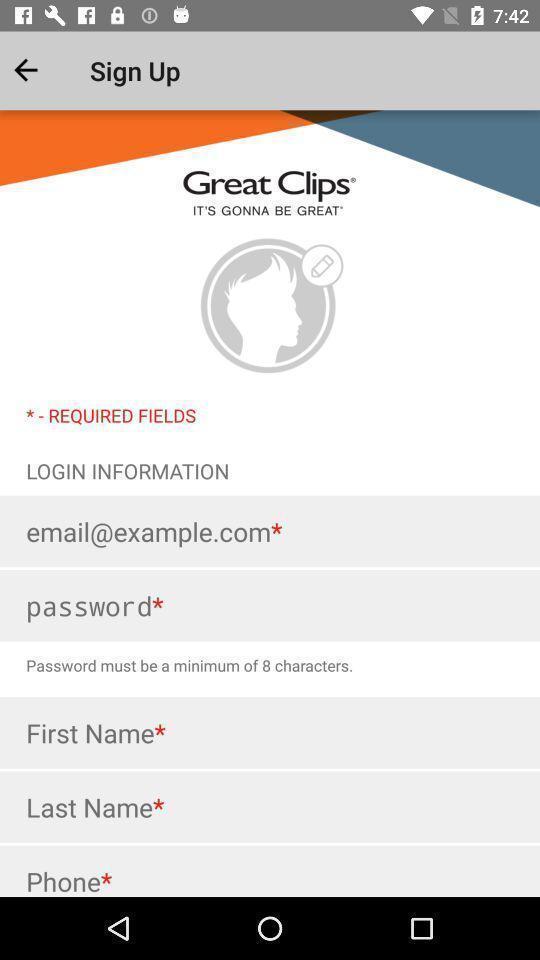Describe the content in this image. Sign in page for an app. 